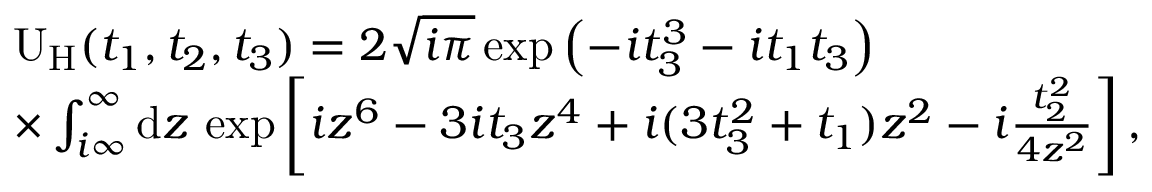<formula> <loc_0><loc_0><loc_500><loc_500>\begin{array} { r l } & { U _ { H } ( t _ { 1 } , t _ { 2 } , t _ { 3 } ) = 2 \sqrt { i \pi } \exp \left ( - i t _ { 3 } ^ { 3 } - i t _ { 1 } t _ { 3 } \right ) } \\ & { \times \int _ { i \infty } ^ { \infty } d z \, \exp \left [ i z ^ { 6 } - 3 i t _ { 3 } z ^ { 4 } + i ( 3 t _ { 3 } ^ { 2 } + t _ { 1 } ) z ^ { 2 } - i \frac { t _ { 2 } ^ { 2 } } { 4 z ^ { 2 } } \right ] , } \end{array}</formula> 